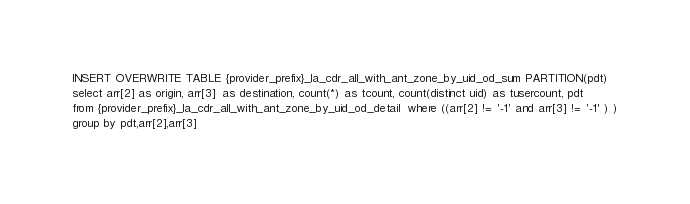Convert code to text. <code><loc_0><loc_0><loc_500><loc_500><_SQL_>INSERT OVERWRITE TABLE {provider_prefix}_la_cdr_all_with_ant_zone_by_uid_od_sum PARTITION(pdt)  
select arr[2] as origin, arr[3]  as destination, count(*) as tcount, count(distinct uid) as tusercount, pdt
from {provider_prefix}_la_cdr_all_with_ant_zone_by_uid_od_detail  where ((arr[2] != '-1' and arr[3] != '-1' ) )
group by pdt,arr[2],arr[3]</code> 